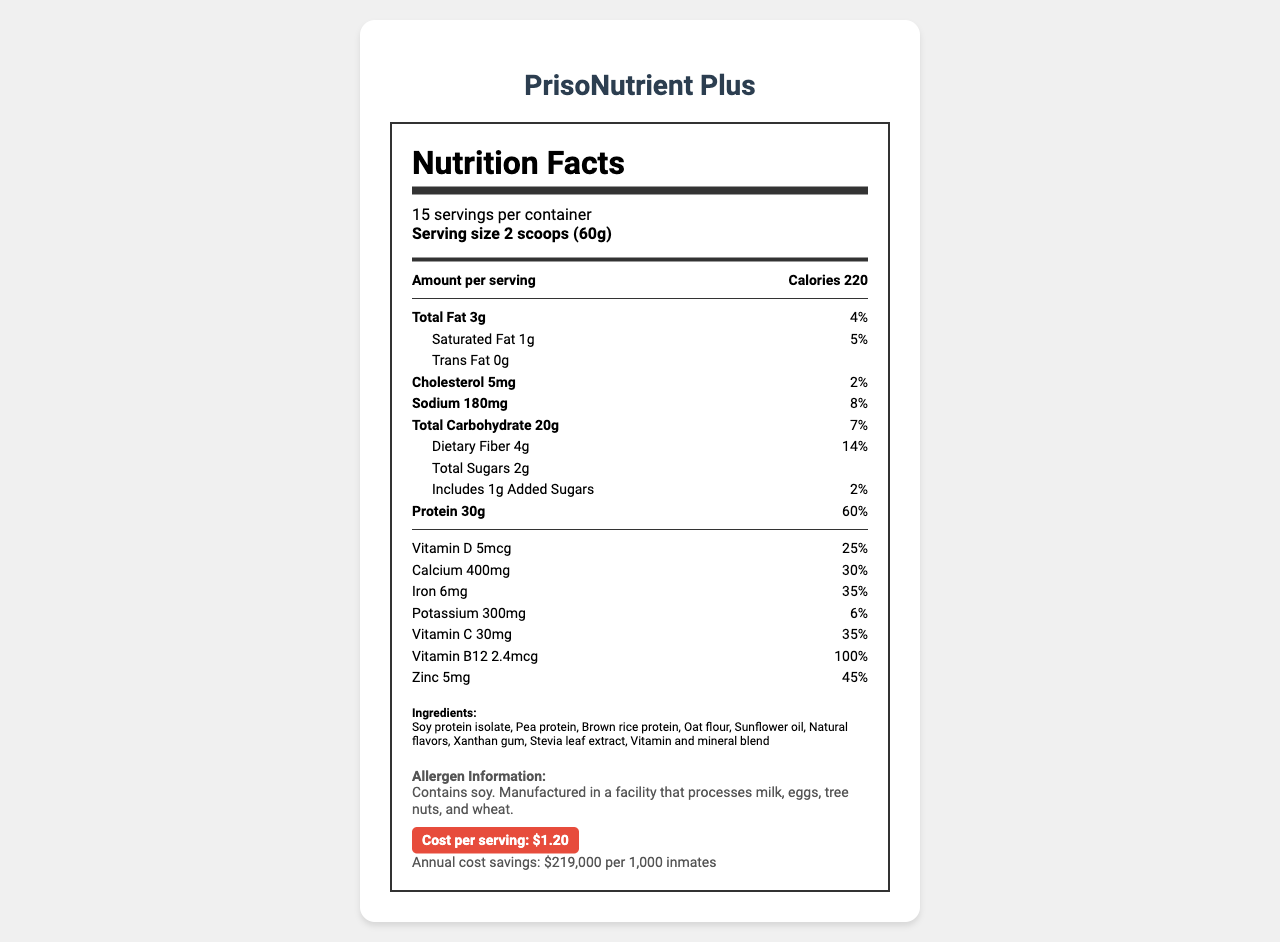How many grams of protein are in each serving of PrisoNutrient Plus? The document shows that each serving contains 30 grams of protein.
Answer: 30g How much saturated fat is in one serving? The document lists that there is 1 gram of saturated fat per serving.
Answer: 1g What percentage of the daily value of calcium does one serving provide? The nutrition facts state that one serving provides 30% of the daily value for calcium.
Answer: 30% Which ingredient is listed first in the ingredients list? In the ingredients section, soy protein isolate is listed first.
Answer: Soy protein isolate What allergens are present in PrisoNutrient Plus? The allergen information in the document states that the product contains soy.
Answer: Contains soy. What is the serving size of PrisoNutrient Plus? A. 1 scoop B. 2 scoops C. 3 scoops D. 4 scoops The serving size listed in the document is 2 scoops (60g).
Answer: B What is the cost per serving of PrisoNutrient Plus? A. $0.50 B. $1.00 C. $1.20 D. $2.00 The document specifies that the cost per serving is $1.20.
Answer: C Does PrisoNutrient Plus contain trans fat? The nutrition facts label lists 0 grams of trans fat.
Answer: No Summarize the main benefits of PrisoNutrient Plus in terms of inmates' health and costs. The document describes the health benefits such as muscle maintenance, bone health, immune function, and weight management. It also emphasizes the annual cost savings and includes additional information on its sustainability features and rehabilitation aspects.
Answer: PrisoNutrient Plus is a budget-friendly, high-protein food supplement designed to support inmates' health. It provides significant amounts of protein, calcium, iron, and various vitamins. It aids muscle maintenance, promotes bone health, boosts immune function, and helps manage weight. Additionally, it offers cost savings of $219,000 per 1,000 inmates annually. What is the annual cost savings provided by PrisoNutrient Plus per 1,000 inmates? The document states that the annual cost savings per 1,000 inmates is $219,000.
Answer: $219,000 What are the primary protein sources in PrisoNutrient Plus? The ingredients list in the document includes soy protein isolate, pea protein, and brown rice protein as the primary protein sources.
Answer: Soy protein isolate, Pea protein, Brown rice protein What is the function of vitamin B12 in PrisoNutrient Plus? The document lists the amount and daily value percentage of vitamin B12 but does not describe its specific function.
Answer: Not enough information How many servings are there per container of PrisoNutrient Plus? The document shows that there are 15 servings per container.
Answer: 15 servings What health benefits does PrisoNutrient Plus provide? The document lists these health benefits in a dedicated section.
Answer: Supports muscle maintenance and repair, Promotes bone health, Boosts immune function, Aids in weight management What sustainability features are associated with PrisoNutrient Plus? The document outlines these sustainability features.
Answer: Plant-based protein sources, Recyclable packaging, Locally sourced ingredients where possible 